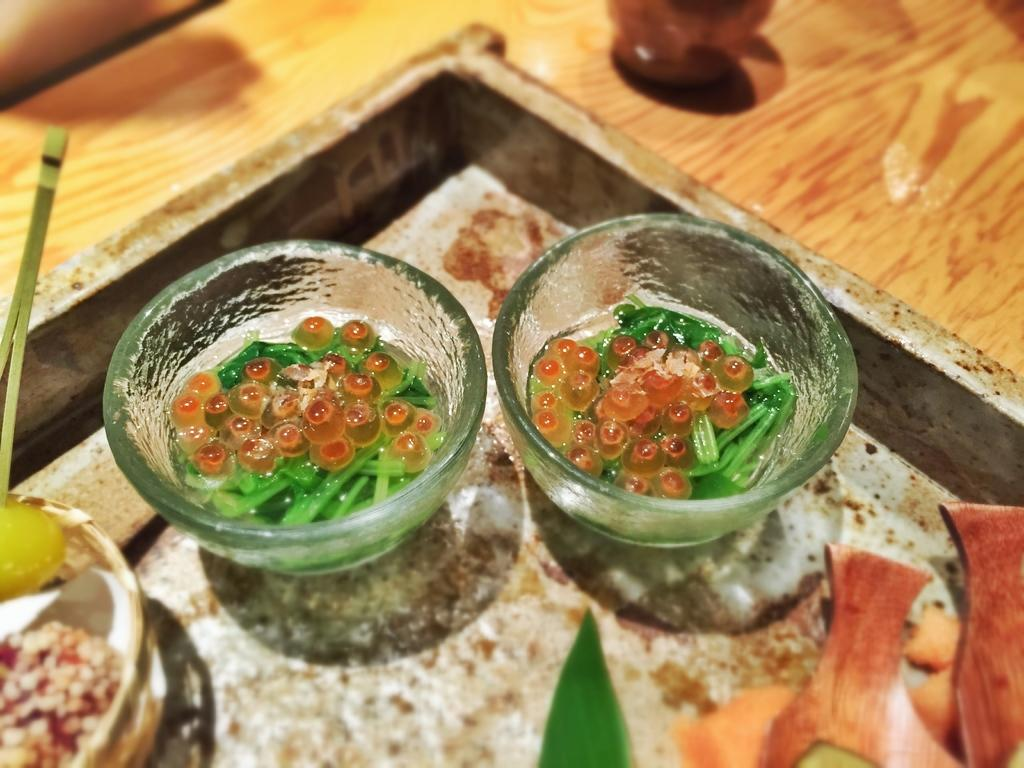What type of containers are present in the image? There are bowls in the image. What is used to hold the bowls in the image? There is a holder in the image to hold the bowls. What can be found inside the bowls in the image? There are food items in the image. What other objects are present on the tray in the image? There are other objects on the tray in the image. What is visible on the table in the background of the image? There is another object on the table in the background of the image. What holiday is being celebrated in the image? There is no indication of a holiday being celebrated in the image. What type of friction is present between the bowls and the holder in the image? The concept of friction is not applicable to the interaction between the bowls and the holder in the image, as they are stationary objects. 